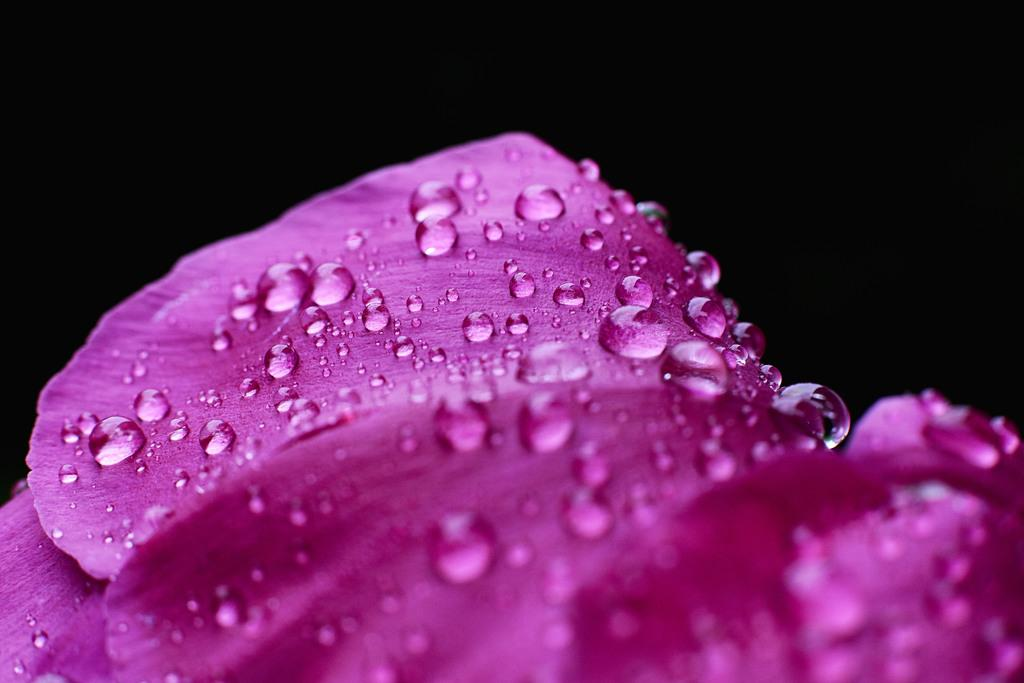What is the main subject of the image? The main subject of the image is a flower. What can be observed on the flower in the image? There are water drops on the flower in the image. How many records can be seen stacked next to the flower in the image? There are no records present in the image; it only features a flower with water drops on it. 